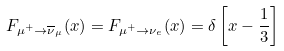Convert formula to latex. <formula><loc_0><loc_0><loc_500><loc_500>F _ { \mu ^ { + } \to \overline { \nu } _ { \mu } } ( x ) = F _ { \mu ^ { + } \to \nu _ { e } } ( x ) = \delta \left [ x - \frac { 1 } { 3 } \right ]</formula> 